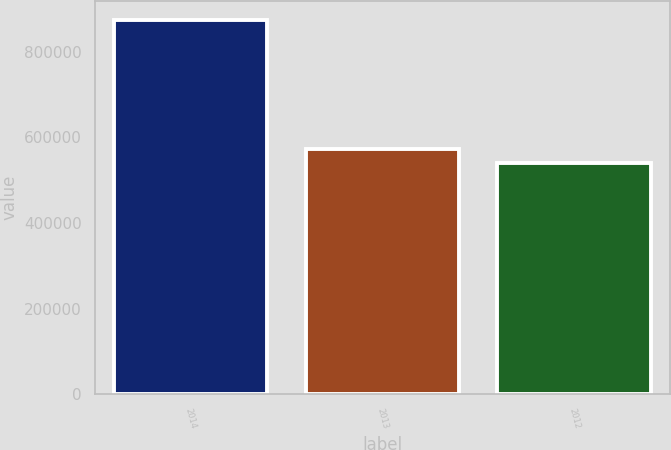Convert chart. <chart><loc_0><loc_0><loc_500><loc_500><bar_chart><fcel>2014<fcel>2013<fcel>2012<nl><fcel>874592<fcel>573013<fcel>539504<nl></chart> 